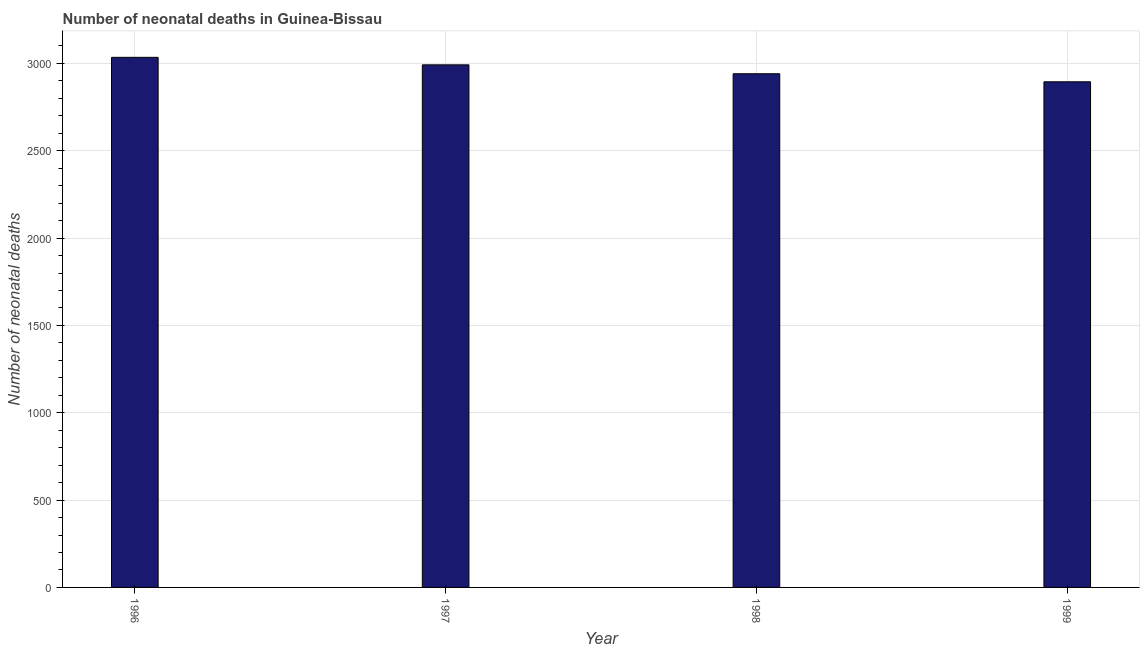Does the graph contain any zero values?
Offer a very short reply. No. What is the title of the graph?
Provide a short and direct response. Number of neonatal deaths in Guinea-Bissau. What is the label or title of the X-axis?
Your answer should be compact. Year. What is the label or title of the Y-axis?
Your answer should be compact. Number of neonatal deaths. What is the number of neonatal deaths in 1997?
Your answer should be compact. 2992. Across all years, what is the maximum number of neonatal deaths?
Your response must be concise. 3035. Across all years, what is the minimum number of neonatal deaths?
Keep it short and to the point. 2895. In which year was the number of neonatal deaths maximum?
Provide a succinct answer. 1996. In which year was the number of neonatal deaths minimum?
Provide a succinct answer. 1999. What is the sum of the number of neonatal deaths?
Your answer should be very brief. 1.19e+04. What is the average number of neonatal deaths per year?
Keep it short and to the point. 2965. What is the median number of neonatal deaths?
Your answer should be very brief. 2966.5. What is the ratio of the number of neonatal deaths in 1997 to that in 1999?
Your answer should be very brief. 1.03. Is the difference between the number of neonatal deaths in 1997 and 1998 greater than the difference between any two years?
Your response must be concise. No. What is the difference between the highest and the second highest number of neonatal deaths?
Keep it short and to the point. 43. Is the sum of the number of neonatal deaths in 1996 and 1998 greater than the maximum number of neonatal deaths across all years?
Offer a terse response. Yes. What is the difference between the highest and the lowest number of neonatal deaths?
Offer a terse response. 140. How many bars are there?
Your response must be concise. 4. Are all the bars in the graph horizontal?
Ensure brevity in your answer.  No. How many years are there in the graph?
Ensure brevity in your answer.  4. Are the values on the major ticks of Y-axis written in scientific E-notation?
Provide a succinct answer. No. What is the Number of neonatal deaths in 1996?
Keep it short and to the point. 3035. What is the Number of neonatal deaths in 1997?
Offer a very short reply. 2992. What is the Number of neonatal deaths in 1998?
Offer a terse response. 2941. What is the Number of neonatal deaths in 1999?
Your answer should be compact. 2895. What is the difference between the Number of neonatal deaths in 1996 and 1997?
Offer a terse response. 43. What is the difference between the Number of neonatal deaths in 1996 and 1998?
Keep it short and to the point. 94. What is the difference between the Number of neonatal deaths in 1996 and 1999?
Provide a succinct answer. 140. What is the difference between the Number of neonatal deaths in 1997 and 1998?
Your response must be concise. 51. What is the difference between the Number of neonatal deaths in 1997 and 1999?
Keep it short and to the point. 97. What is the ratio of the Number of neonatal deaths in 1996 to that in 1998?
Your answer should be compact. 1.03. What is the ratio of the Number of neonatal deaths in 1996 to that in 1999?
Keep it short and to the point. 1.05. What is the ratio of the Number of neonatal deaths in 1997 to that in 1998?
Provide a succinct answer. 1.02. What is the ratio of the Number of neonatal deaths in 1997 to that in 1999?
Ensure brevity in your answer.  1.03. 